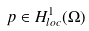<formula> <loc_0><loc_0><loc_500><loc_500>p \in H ^ { 1 } _ { l o c } ( \Omega )</formula> 